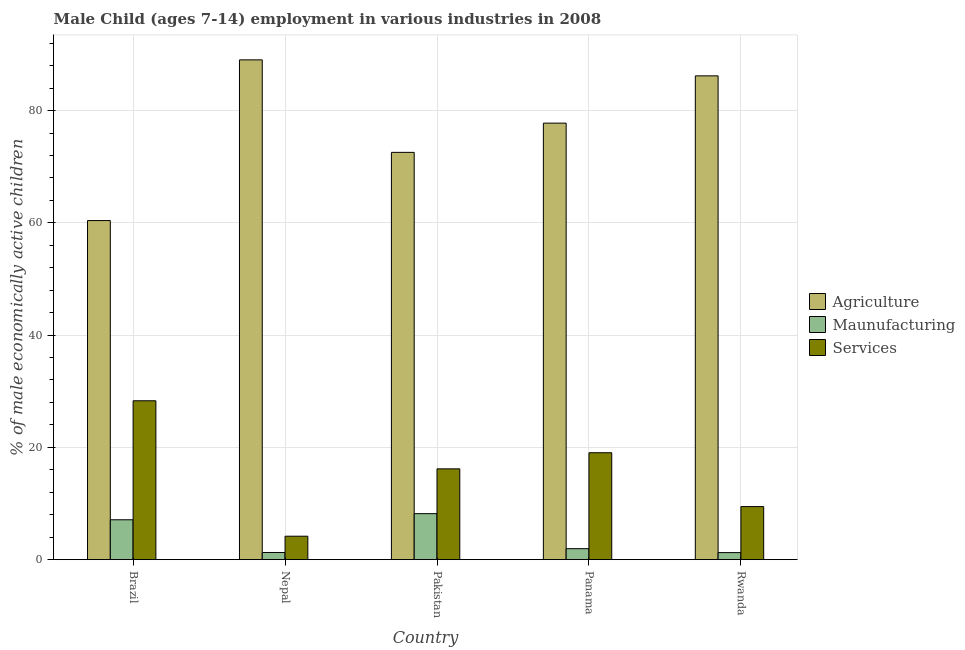How many groups of bars are there?
Offer a very short reply. 5. Are the number of bars per tick equal to the number of legend labels?
Give a very brief answer. Yes. How many bars are there on the 3rd tick from the left?
Offer a very short reply. 3. How many bars are there on the 3rd tick from the right?
Provide a short and direct response. 3. What is the percentage of economically active children in manufacturing in Rwanda?
Provide a short and direct response. 1.25. Across all countries, what is the maximum percentage of economically active children in agriculture?
Keep it short and to the point. 89.03. In which country was the percentage of economically active children in agriculture maximum?
Offer a very short reply. Nepal. In which country was the percentage of economically active children in services minimum?
Your response must be concise. Nepal. What is the total percentage of economically active children in services in the graph?
Make the answer very short. 77.13. What is the difference between the percentage of economically active children in manufacturing in Brazil and that in Pakistan?
Provide a short and direct response. -1.09. What is the difference between the percentage of economically active children in services in Rwanda and the percentage of economically active children in manufacturing in Pakistan?
Keep it short and to the point. 1.26. What is the average percentage of economically active children in services per country?
Offer a very short reply. 15.43. What is the difference between the percentage of economically active children in manufacturing and percentage of economically active children in agriculture in Panama?
Keep it short and to the point. -75.81. What is the ratio of the percentage of economically active children in agriculture in Nepal to that in Panama?
Provide a succinct answer. 1.14. Is the percentage of economically active children in manufacturing in Pakistan less than that in Rwanda?
Offer a terse response. No. What is the difference between the highest and the second highest percentage of economically active children in services?
Provide a short and direct response. 9.26. What is the difference between the highest and the lowest percentage of economically active children in agriculture?
Give a very brief answer. 28.63. In how many countries, is the percentage of economically active children in manufacturing greater than the average percentage of economically active children in manufacturing taken over all countries?
Offer a terse response. 2. Is the sum of the percentage of economically active children in services in Nepal and Rwanda greater than the maximum percentage of economically active children in manufacturing across all countries?
Your answer should be very brief. Yes. What does the 1st bar from the left in Rwanda represents?
Your response must be concise. Agriculture. What does the 1st bar from the right in Nepal represents?
Give a very brief answer. Services. Is it the case that in every country, the sum of the percentage of economically active children in agriculture and percentage of economically active children in manufacturing is greater than the percentage of economically active children in services?
Provide a short and direct response. Yes. How many bars are there?
Provide a succinct answer. 15. Are all the bars in the graph horizontal?
Provide a short and direct response. No. Are the values on the major ticks of Y-axis written in scientific E-notation?
Provide a succinct answer. No. Does the graph contain any zero values?
Provide a succinct answer. No. Does the graph contain grids?
Offer a very short reply. Yes. How many legend labels are there?
Provide a short and direct response. 3. How are the legend labels stacked?
Make the answer very short. Vertical. What is the title of the graph?
Provide a short and direct response. Male Child (ages 7-14) employment in various industries in 2008. Does "Social Protection and Labor" appear as one of the legend labels in the graph?
Ensure brevity in your answer.  No. What is the label or title of the Y-axis?
Keep it short and to the point. % of male economically active children. What is the % of male economically active children in Agriculture in Brazil?
Make the answer very short. 60.4. What is the % of male economically active children in Services in Brazil?
Keep it short and to the point. 28.3. What is the % of male economically active children of Agriculture in Nepal?
Your response must be concise. 89.03. What is the % of male economically active children of Maunufacturing in Nepal?
Make the answer very short. 1.27. What is the % of male economically active children in Services in Nepal?
Give a very brief answer. 4.17. What is the % of male economically active children of Agriculture in Pakistan?
Ensure brevity in your answer.  72.55. What is the % of male economically active children in Maunufacturing in Pakistan?
Provide a short and direct response. 8.19. What is the % of male economically active children of Services in Pakistan?
Provide a short and direct response. 16.17. What is the % of male economically active children in Agriculture in Panama?
Make the answer very short. 77.76. What is the % of male economically active children of Maunufacturing in Panama?
Your answer should be compact. 1.95. What is the % of male economically active children in Services in Panama?
Your answer should be compact. 19.04. What is the % of male economically active children in Agriculture in Rwanda?
Keep it short and to the point. 86.18. What is the % of male economically active children in Maunufacturing in Rwanda?
Keep it short and to the point. 1.25. What is the % of male economically active children of Services in Rwanda?
Your answer should be compact. 9.45. Across all countries, what is the maximum % of male economically active children of Agriculture?
Your answer should be compact. 89.03. Across all countries, what is the maximum % of male economically active children in Maunufacturing?
Make the answer very short. 8.19. Across all countries, what is the maximum % of male economically active children of Services?
Give a very brief answer. 28.3. Across all countries, what is the minimum % of male economically active children of Agriculture?
Make the answer very short. 60.4. Across all countries, what is the minimum % of male economically active children in Services?
Your answer should be very brief. 4.17. What is the total % of male economically active children in Agriculture in the graph?
Provide a succinct answer. 385.92. What is the total % of male economically active children of Maunufacturing in the graph?
Give a very brief answer. 19.76. What is the total % of male economically active children of Services in the graph?
Offer a terse response. 77.13. What is the difference between the % of male economically active children in Agriculture in Brazil and that in Nepal?
Provide a succinct answer. -28.63. What is the difference between the % of male economically active children of Maunufacturing in Brazil and that in Nepal?
Your answer should be very brief. 5.83. What is the difference between the % of male economically active children in Services in Brazil and that in Nepal?
Give a very brief answer. 24.13. What is the difference between the % of male economically active children of Agriculture in Brazil and that in Pakistan?
Offer a terse response. -12.15. What is the difference between the % of male economically active children of Maunufacturing in Brazil and that in Pakistan?
Offer a very short reply. -1.09. What is the difference between the % of male economically active children in Services in Brazil and that in Pakistan?
Keep it short and to the point. 12.13. What is the difference between the % of male economically active children of Agriculture in Brazil and that in Panama?
Offer a terse response. -17.36. What is the difference between the % of male economically active children of Maunufacturing in Brazil and that in Panama?
Provide a succinct answer. 5.15. What is the difference between the % of male economically active children in Services in Brazil and that in Panama?
Your response must be concise. 9.26. What is the difference between the % of male economically active children in Agriculture in Brazil and that in Rwanda?
Your answer should be very brief. -25.78. What is the difference between the % of male economically active children of Maunufacturing in Brazil and that in Rwanda?
Offer a very short reply. 5.85. What is the difference between the % of male economically active children in Services in Brazil and that in Rwanda?
Provide a succinct answer. 18.85. What is the difference between the % of male economically active children in Agriculture in Nepal and that in Pakistan?
Offer a terse response. 16.48. What is the difference between the % of male economically active children in Maunufacturing in Nepal and that in Pakistan?
Make the answer very short. -6.92. What is the difference between the % of male economically active children of Services in Nepal and that in Pakistan?
Provide a short and direct response. -12. What is the difference between the % of male economically active children in Agriculture in Nepal and that in Panama?
Offer a very short reply. 11.27. What is the difference between the % of male economically active children in Maunufacturing in Nepal and that in Panama?
Give a very brief answer. -0.68. What is the difference between the % of male economically active children in Services in Nepal and that in Panama?
Offer a terse response. -14.87. What is the difference between the % of male economically active children in Agriculture in Nepal and that in Rwanda?
Your response must be concise. 2.85. What is the difference between the % of male economically active children of Maunufacturing in Nepal and that in Rwanda?
Offer a terse response. 0.02. What is the difference between the % of male economically active children of Services in Nepal and that in Rwanda?
Offer a very short reply. -5.28. What is the difference between the % of male economically active children of Agriculture in Pakistan and that in Panama?
Keep it short and to the point. -5.21. What is the difference between the % of male economically active children in Maunufacturing in Pakistan and that in Panama?
Offer a very short reply. 6.24. What is the difference between the % of male economically active children of Services in Pakistan and that in Panama?
Give a very brief answer. -2.87. What is the difference between the % of male economically active children in Agriculture in Pakistan and that in Rwanda?
Give a very brief answer. -13.63. What is the difference between the % of male economically active children of Maunufacturing in Pakistan and that in Rwanda?
Your answer should be compact. 6.94. What is the difference between the % of male economically active children in Services in Pakistan and that in Rwanda?
Offer a terse response. 6.72. What is the difference between the % of male economically active children in Agriculture in Panama and that in Rwanda?
Make the answer very short. -8.42. What is the difference between the % of male economically active children in Maunufacturing in Panama and that in Rwanda?
Provide a succinct answer. 0.7. What is the difference between the % of male economically active children in Services in Panama and that in Rwanda?
Give a very brief answer. 9.59. What is the difference between the % of male economically active children of Agriculture in Brazil and the % of male economically active children of Maunufacturing in Nepal?
Provide a succinct answer. 59.13. What is the difference between the % of male economically active children of Agriculture in Brazil and the % of male economically active children of Services in Nepal?
Give a very brief answer. 56.23. What is the difference between the % of male economically active children of Maunufacturing in Brazil and the % of male economically active children of Services in Nepal?
Provide a short and direct response. 2.93. What is the difference between the % of male economically active children of Agriculture in Brazil and the % of male economically active children of Maunufacturing in Pakistan?
Provide a short and direct response. 52.21. What is the difference between the % of male economically active children of Agriculture in Brazil and the % of male economically active children of Services in Pakistan?
Make the answer very short. 44.23. What is the difference between the % of male economically active children of Maunufacturing in Brazil and the % of male economically active children of Services in Pakistan?
Your answer should be compact. -9.07. What is the difference between the % of male economically active children of Agriculture in Brazil and the % of male economically active children of Maunufacturing in Panama?
Give a very brief answer. 58.45. What is the difference between the % of male economically active children in Agriculture in Brazil and the % of male economically active children in Services in Panama?
Make the answer very short. 41.36. What is the difference between the % of male economically active children in Maunufacturing in Brazil and the % of male economically active children in Services in Panama?
Keep it short and to the point. -11.94. What is the difference between the % of male economically active children of Agriculture in Brazil and the % of male economically active children of Maunufacturing in Rwanda?
Provide a short and direct response. 59.15. What is the difference between the % of male economically active children in Agriculture in Brazil and the % of male economically active children in Services in Rwanda?
Your answer should be very brief. 50.95. What is the difference between the % of male economically active children of Maunufacturing in Brazil and the % of male economically active children of Services in Rwanda?
Provide a succinct answer. -2.35. What is the difference between the % of male economically active children of Agriculture in Nepal and the % of male economically active children of Maunufacturing in Pakistan?
Offer a terse response. 80.84. What is the difference between the % of male economically active children in Agriculture in Nepal and the % of male economically active children in Services in Pakistan?
Your response must be concise. 72.86. What is the difference between the % of male economically active children of Maunufacturing in Nepal and the % of male economically active children of Services in Pakistan?
Your answer should be very brief. -14.9. What is the difference between the % of male economically active children of Agriculture in Nepal and the % of male economically active children of Maunufacturing in Panama?
Give a very brief answer. 87.08. What is the difference between the % of male economically active children in Agriculture in Nepal and the % of male economically active children in Services in Panama?
Keep it short and to the point. 69.99. What is the difference between the % of male economically active children in Maunufacturing in Nepal and the % of male economically active children in Services in Panama?
Offer a terse response. -17.77. What is the difference between the % of male economically active children in Agriculture in Nepal and the % of male economically active children in Maunufacturing in Rwanda?
Keep it short and to the point. 87.78. What is the difference between the % of male economically active children of Agriculture in Nepal and the % of male economically active children of Services in Rwanda?
Ensure brevity in your answer.  79.58. What is the difference between the % of male economically active children of Maunufacturing in Nepal and the % of male economically active children of Services in Rwanda?
Keep it short and to the point. -8.18. What is the difference between the % of male economically active children in Agriculture in Pakistan and the % of male economically active children in Maunufacturing in Panama?
Make the answer very short. 70.6. What is the difference between the % of male economically active children in Agriculture in Pakistan and the % of male economically active children in Services in Panama?
Your answer should be very brief. 53.51. What is the difference between the % of male economically active children in Maunufacturing in Pakistan and the % of male economically active children in Services in Panama?
Give a very brief answer. -10.85. What is the difference between the % of male economically active children of Agriculture in Pakistan and the % of male economically active children of Maunufacturing in Rwanda?
Offer a very short reply. 71.3. What is the difference between the % of male economically active children of Agriculture in Pakistan and the % of male economically active children of Services in Rwanda?
Keep it short and to the point. 63.1. What is the difference between the % of male economically active children in Maunufacturing in Pakistan and the % of male economically active children in Services in Rwanda?
Make the answer very short. -1.26. What is the difference between the % of male economically active children of Agriculture in Panama and the % of male economically active children of Maunufacturing in Rwanda?
Your response must be concise. 76.51. What is the difference between the % of male economically active children of Agriculture in Panama and the % of male economically active children of Services in Rwanda?
Offer a very short reply. 68.31. What is the average % of male economically active children of Agriculture per country?
Offer a very short reply. 77.18. What is the average % of male economically active children of Maunufacturing per country?
Provide a short and direct response. 3.95. What is the average % of male economically active children in Services per country?
Your answer should be very brief. 15.43. What is the difference between the % of male economically active children in Agriculture and % of male economically active children in Maunufacturing in Brazil?
Offer a very short reply. 53.3. What is the difference between the % of male economically active children in Agriculture and % of male economically active children in Services in Brazil?
Provide a succinct answer. 32.1. What is the difference between the % of male economically active children in Maunufacturing and % of male economically active children in Services in Brazil?
Your answer should be very brief. -21.2. What is the difference between the % of male economically active children of Agriculture and % of male economically active children of Maunufacturing in Nepal?
Give a very brief answer. 87.76. What is the difference between the % of male economically active children of Agriculture and % of male economically active children of Services in Nepal?
Offer a very short reply. 84.86. What is the difference between the % of male economically active children in Agriculture and % of male economically active children in Maunufacturing in Pakistan?
Your response must be concise. 64.36. What is the difference between the % of male economically active children in Agriculture and % of male economically active children in Services in Pakistan?
Provide a succinct answer. 56.38. What is the difference between the % of male economically active children in Maunufacturing and % of male economically active children in Services in Pakistan?
Your answer should be compact. -7.98. What is the difference between the % of male economically active children of Agriculture and % of male economically active children of Maunufacturing in Panama?
Your answer should be very brief. 75.81. What is the difference between the % of male economically active children of Agriculture and % of male economically active children of Services in Panama?
Offer a very short reply. 58.72. What is the difference between the % of male economically active children in Maunufacturing and % of male economically active children in Services in Panama?
Provide a short and direct response. -17.09. What is the difference between the % of male economically active children in Agriculture and % of male economically active children in Maunufacturing in Rwanda?
Offer a terse response. 84.93. What is the difference between the % of male economically active children of Agriculture and % of male economically active children of Services in Rwanda?
Your answer should be compact. 76.73. What is the difference between the % of male economically active children of Maunufacturing and % of male economically active children of Services in Rwanda?
Give a very brief answer. -8.2. What is the ratio of the % of male economically active children of Agriculture in Brazil to that in Nepal?
Offer a very short reply. 0.68. What is the ratio of the % of male economically active children of Maunufacturing in Brazil to that in Nepal?
Provide a short and direct response. 5.59. What is the ratio of the % of male economically active children of Services in Brazil to that in Nepal?
Give a very brief answer. 6.79. What is the ratio of the % of male economically active children of Agriculture in Brazil to that in Pakistan?
Provide a succinct answer. 0.83. What is the ratio of the % of male economically active children in Maunufacturing in Brazil to that in Pakistan?
Offer a very short reply. 0.87. What is the ratio of the % of male economically active children of Services in Brazil to that in Pakistan?
Give a very brief answer. 1.75. What is the ratio of the % of male economically active children of Agriculture in Brazil to that in Panama?
Offer a very short reply. 0.78. What is the ratio of the % of male economically active children of Maunufacturing in Brazil to that in Panama?
Your answer should be very brief. 3.64. What is the ratio of the % of male economically active children of Services in Brazil to that in Panama?
Ensure brevity in your answer.  1.49. What is the ratio of the % of male economically active children of Agriculture in Brazil to that in Rwanda?
Your response must be concise. 0.7. What is the ratio of the % of male economically active children in Maunufacturing in Brazil to that in Rwanda?
Offer a very short reply. 5.68. What is the ratio of the % of male economically active children in Services in Brazil to that in Rwanda?
Your answer should be very brief. 2.99. What is the ratio of the % of male economically active children in Agriculture in Nepal to that in Pakistan?
Provide a succinct answer. 1.23. What is the ratio of the % of male economically active children in Maunufacturing in Nepal to that in Pakistan?
Keep it short and to the point. 0.16. What is the ratio of the % of male economically active children of Services in Nepal to that in Pakistan?
Offer a terse response. 0.26. What is the ratio of the % of male economically active children in Agriculture in Nepal to that in Panama?
Keep it short and to the point. 1.14. What is the ratio of the % of male economically active children in Maunufacturing in Nepal to that in Panama?
Your answer should be very brief. 0.65. What is the ratio of the % of male economically active children in Services in Nepal to that in Panama?
Make the answer very short. 0.22. What is the ratio of the % of male economically active children in Agriculture in Nepal to that in Rwanda?
Keep it short and to the point. 1.03. What is the ratio of the % of male economically active children in Maunufacturing in Nepal to that in Rwanda?
Your response must be concise. 1.02. What is the ratio of the % of male economically active children in Services in Nepal to that in Rwanda?
Offer a very short reply. 0.44. What is the ratio of the % of male economically active children of Agriculture in Pakistan to that in Panama?
Provide a short and direct response. 0.93. What is the ratio of the % of male economically active children of Maunufacturing in Pakistan to that in Panama?
Provide a succinct answer. 4.2. What is the ratio of the % of male economically active children in Services in Pakistan to that in Panama?
Offer a very short reply. 0.85. What is the ratio of the % of male economically active children of Agriculture in Pakistan to that in Rwanda?
Make the answer very short. 0.84. What is the ratio of the % of male economically active children in Maunufacturing in Pakistan to that in Rwanda?
Provide a succinct answer. 6.55. What is the ratio of the % of male economically active children in Services in Pakistan to that in Rwanda?
Offer a very short reply. 1.71. What is the ratio of the % of male economically active children of Agriculture in Panama to that in Rwanda?
Your response must be concise. 0.9. What is the ratio of the % of male economically active children of Maunufacturing in Panama to that in Rwanda?
Your answer should be very brief. 1.56. What is the ratio of the % of male economically active children of Services in Panama to that in Rwanda?
Provide a short and direct response. 2.01. What is the difference between the highest and the second highest % of male economically active children in Agriculture?
Give a very brief answer. 2.85. What is the difference between the highest and the second highest % of male economically active children of Maunufacturing?
Your answer should be very brief. 1.09. What is the difference between the highest and the second highest % of male economically active children in Services?
Offer a terse response. 9.26. What is the difference between the highest and the lowest % of male economically active children of Agriculture?
Your response must be concise. 28.63. What is the difference between the highest and the lowest % of male economically active children in Maunufacturing?
Offer a very short reply. 6.94. What is the difference between the highest and the lowest % of male economically active children of Services?
Provide a short and direct response. 24.13. 